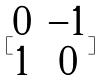<formula> <loc_0><loc_0><loc_500><loc_500>[ \begin{matrix} 0 & - 1 \\ 1 & 0 \end{matrix} ]</formula> 